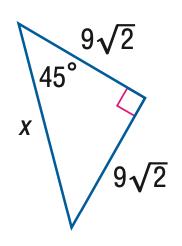Question: Find x.
Choices:
A. 9
B. 6 \sqrt { 6 }
C. 18
D. 18 \sqrt { 2 }
Answer with the letter. Answer: C 